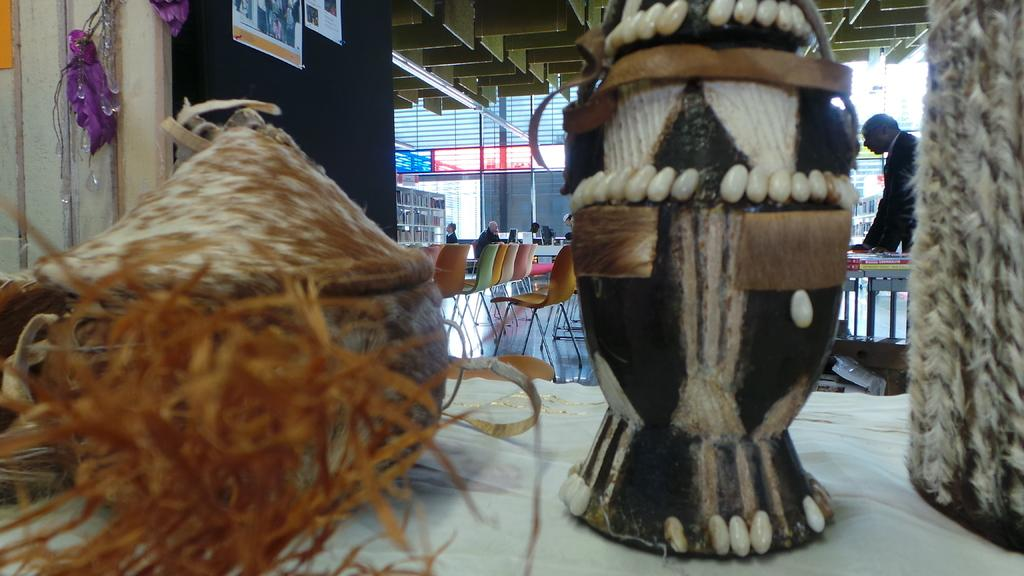What is on the table in the foreground of the image? There are handicrafts on a table in the foreground. What can be seen in the background of the image? There are chairs, tables, a crowd, and buildings in the background. What type of establishment is the image taken in? The image is taken in a restaurant. What type of hen is being celebrated in the image? There is no hen or birthday celebration present in the image. 